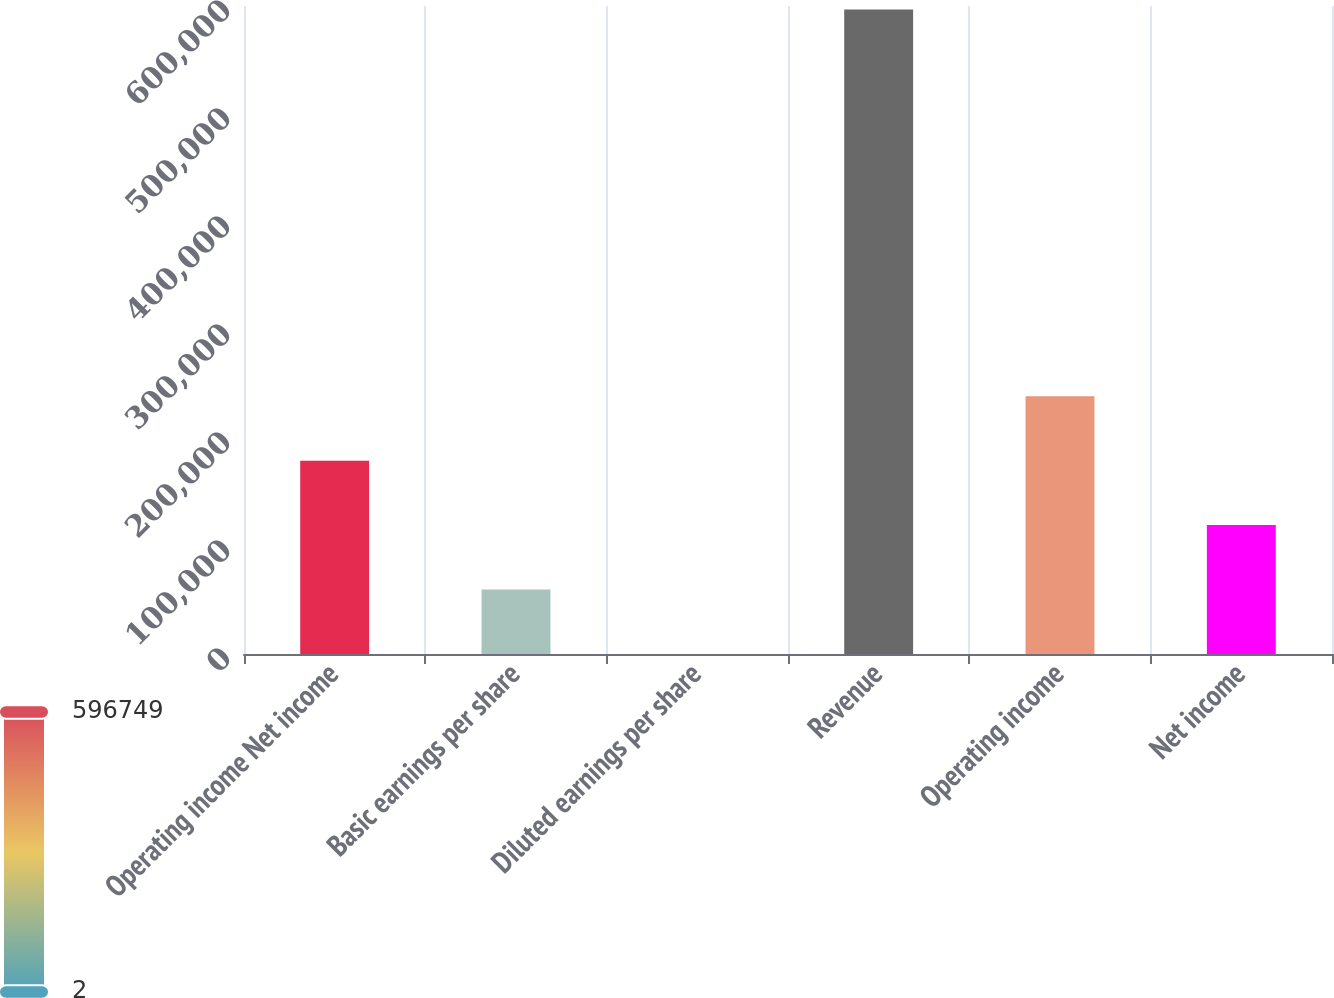Convert chart to OTSL. <chart><loc_0><loc_0><loc_500><loc_500><bar_chart><fcel>Operating income Net income<fcel>Basic earnings per share<fcel>Diluted earnings per share<fcel>Revenue<fcel>Operating income<fcel>Net income<nl><fcel>179026<fcel>59676.7<fcel>1.95<fcel>596749<fcel>238701<fcel>119351<nl></chart> 